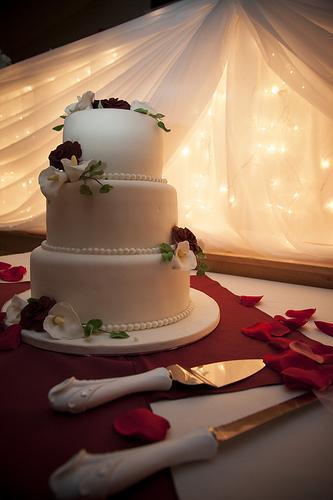How many layers to this cake?
Give a very brief answer. 3. 